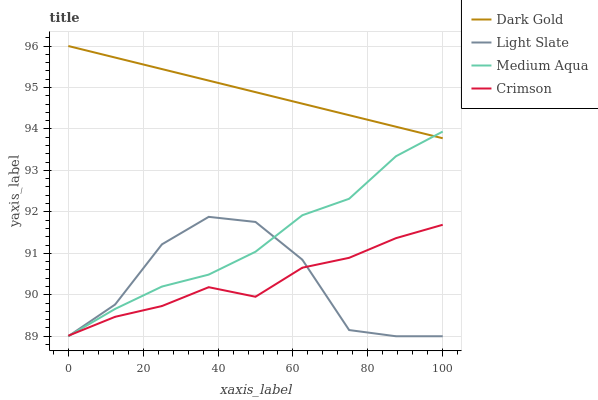Does Crimson have the minimum area under the curve?
Answer yes or no. Yes. Does Dark Gold have the maximum area under the curve?
Answer yes or no. Yes. Does Medium Aqua have the minimum area under the curve?
Answer yes or no. No. Does Medium Aqua have the maximum area under the curve?
Answer yes or no. No. Is Dark Gold the smoothest?
Answer yes or no. Yes. Is Light Slate the roughest?
Answer yes or no. Yes. Is Crimson the smoothest?
Answer yes or no. No. Is Crimson the roughest?
Answer yes or no. No. Does Light Slate have the lowest value?
Answer yes or no. Yes. Does Crimson have the lowest value?
Answer yes or no. No. Does Dark Gold have the highest value?
Answer yes or no. Yes. Does Medium Aqua have the highest value?
Answer yes or no. No. Is Light Slate less than Dark Gold?
Answer yes or no. Yes. Is Dark Gold greater than Crimson?
Answer yes or no. Yes. Does Medium Aqua intersect Crimson?
Answer yes or no. Yes. Is Medium Aqua less than Crimson?
Answer yes or no. No. Is Medium Aqua greater than Crimson?
Answer yes or no. No. Does Light Slate intersect Dark Gold?
Answer yes or no. No. 